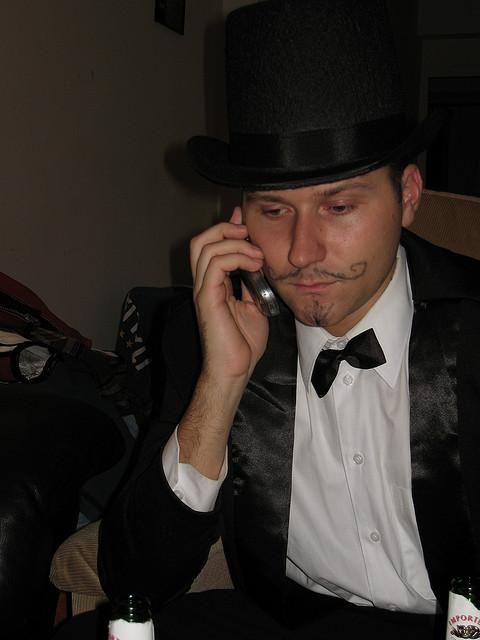What kind of phone is he using? Please explain your reasoning. cellular. The phone he's holding is small and has no wires connected to it. the only choice on this list that matches that description is a cell phone. the others need a wire. 